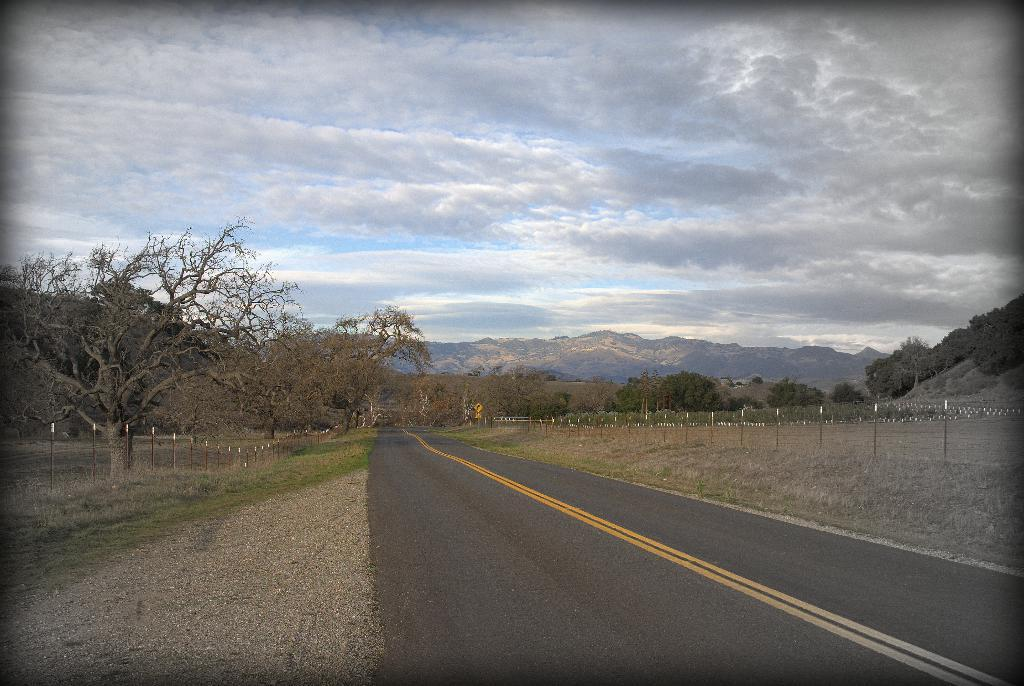What is the main feature of the image? There is a road in the image. What can be seen alongside the road? There are many trees to the side of the road. What is the purpose of the railing in the image? The railing is likely there for safety or to prevent people or vehicles from going off the road. What can be seen in the distance in the image? There are mountains visible in the background, along with clouds and the sky. What channel is the image broadcasting on? The image is not a broadcast or video, so there is no channel associated with it. How many plants are visible in the image? The image does not specifically mention plants; it only mentions trees and the presence of mountains, clouds, and the sky. 